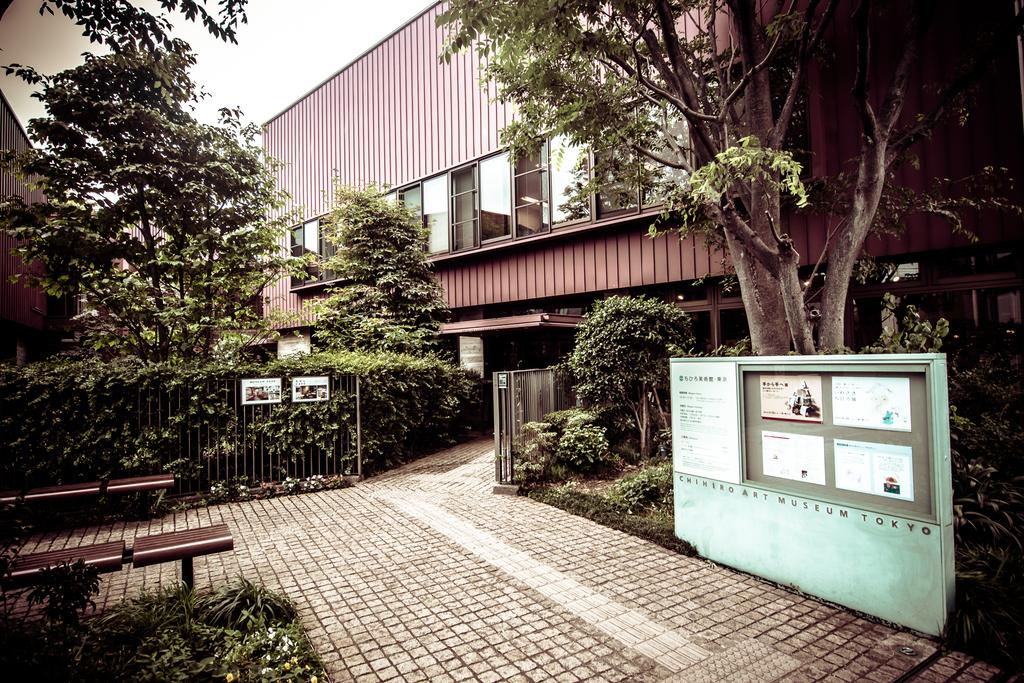What can be seen attached to the railing in the image? There are boards attached to the railing in the image. What type of vegetation is present in the image? There are trees in the image, and they are green. What structure can be seen in the background of the image? There is a shed in the background of the image. What type of windows are visible in the background of the image? There are glass windows in the background of the image. What is the color of the sky in the image? The sky is white in color. Can you hear the quince ripening in the image? There is no mention of quince or any sound in the image, so it is not possible to hear anything related to quince. 